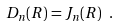<formula> <loc_0><loc_0><loc_500><loc_500>D _ { n } ( R ) = J _ { n } ( R ) \ .</formula> 